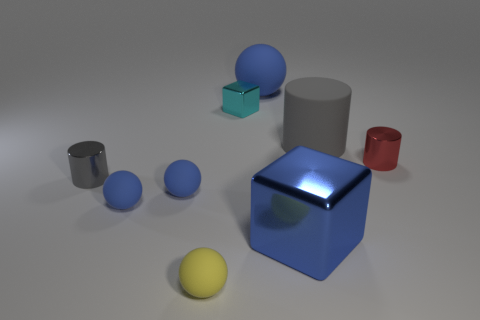What can you tell me about the colors of the objects in the image? The image showcases a variety of colors but remains quite harmonious. There is a blue sphere and a blue cube of a similar shade, which creates a sense of unity. The red metallic cylinder adds a pop of contrasting color, while the gray objects provide a neutral backdrop. Lastly, the yellow sphere adds a subtle but lively detail to the color palette, which brings a bit of warmth to the scene. Do the colors serve a particular purpose in how we perceive the image? Absolutely, the colors guide the viewer's attention and create visual interest. The blue objects might draw the eye first due to their vibrant hue and reflective surface, standing out against the neutral gray. The contrasting red cylinder serves as a focal point, and the warmth of the yellow sphere balances the cooler tones. Collectively, the colors help to differentiate the objects, giving each a distinct identity while contributing to the overall aesthetic of the image. 